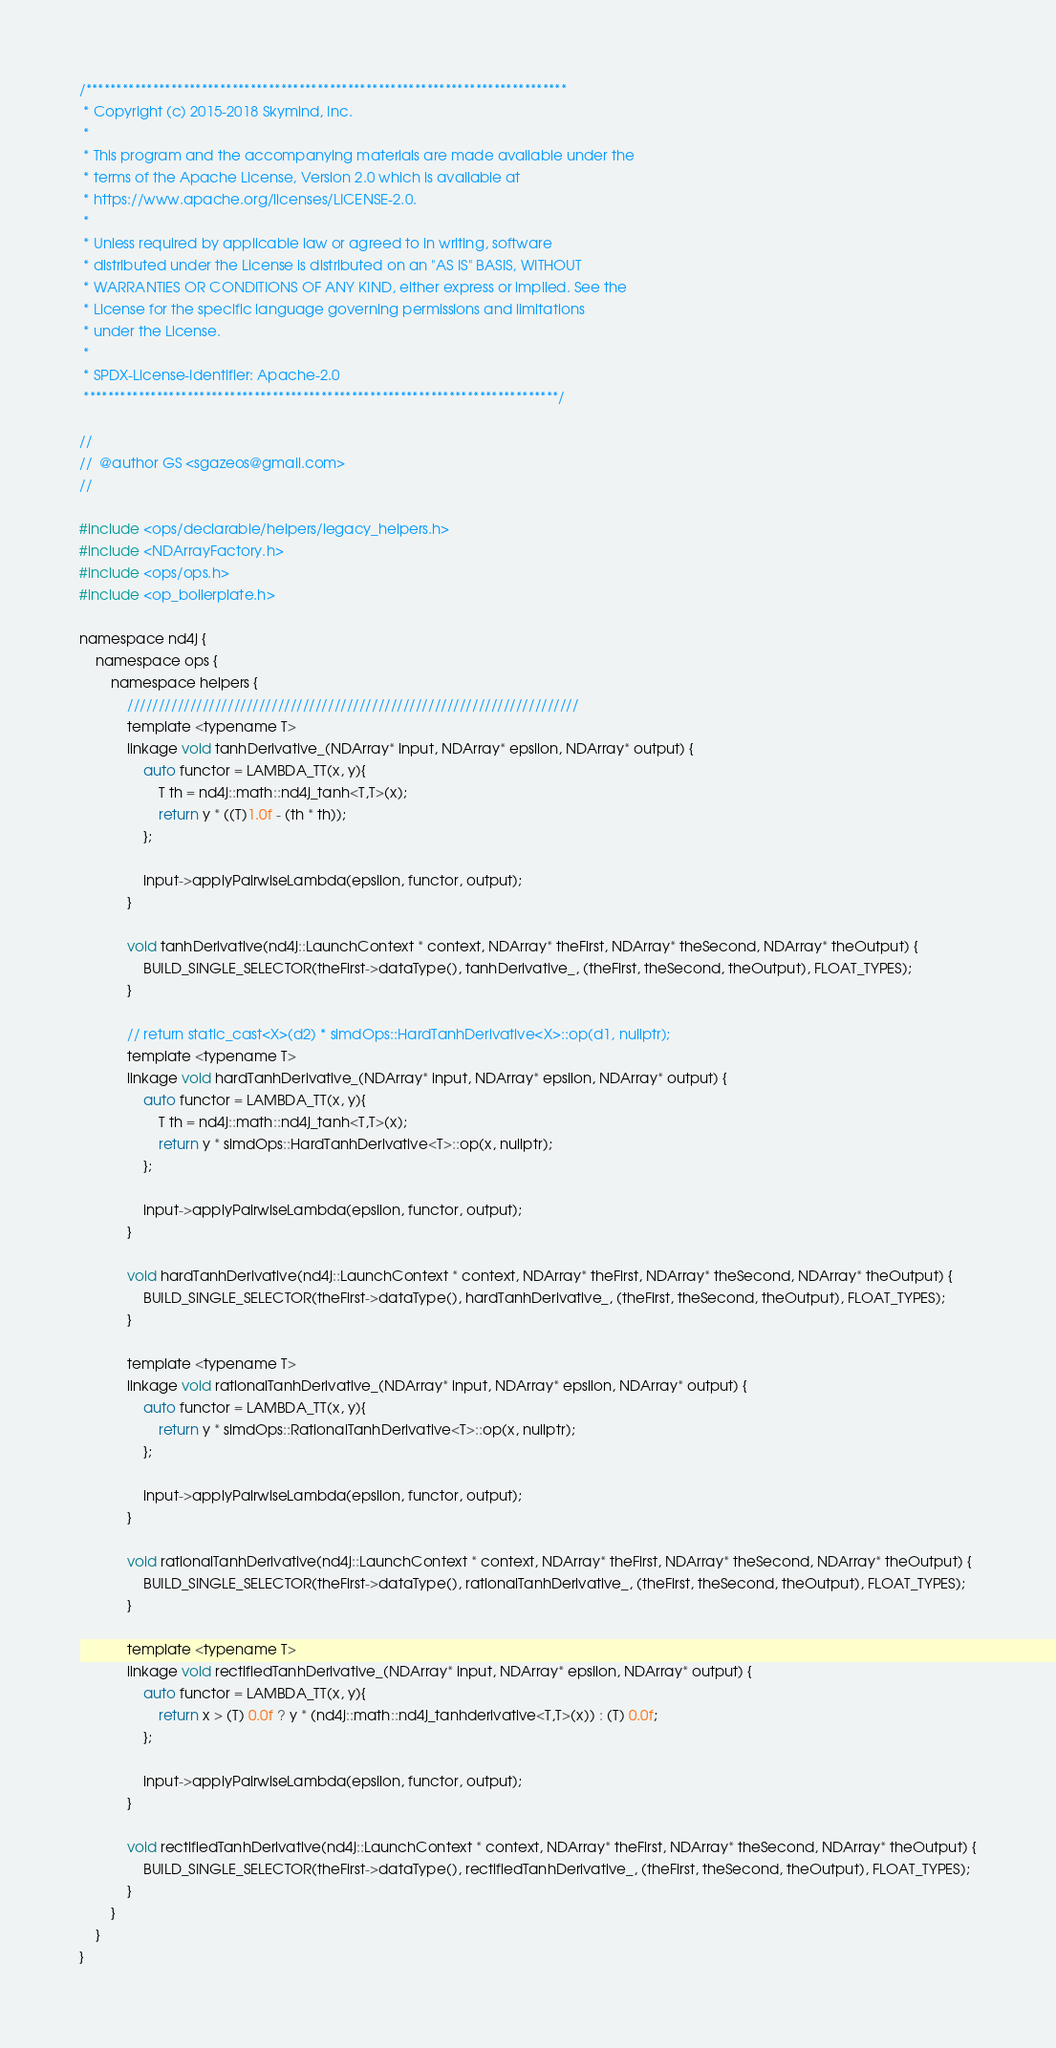Convert code to text. <code><loc_0><loc_0><loc_500><loc_500><_Cuda_>/*******************************************************************************
 * Copyright (c) 2015-2018 Skymind, Inc.
 *
 * This program and the accompanying materials are made available under the
 * terms of the Apache License, Version 2.0 which is available at
 * https://www.apache.org/licenses/LICENSE-2.0.
 *
 * Unless required by applicable law or agreed to in writing, software
 * distributed under the License is distributed on an "AS IS" BASIS, WITHOUT
 * WARRANTIES OR CONDITIONS OF ANY KIND, either express or implied. See the
 * License for the specific language governing permissions and limitations
 * under the License.
 *
 * SPDX-License-Identifier: Apache-2.0
 ******************************************************************************/

//
//  @author GS <sgazeos@gmail.com>
//

#include <ops/declarable/helpers/legacy_helpers.h>
#include <NDArrayFactory.h>
#include <ops/ops.h>
#include <op_boilerplate.h>

namespace nd4j {
    namespace ops {
        namespace helpers {
            ////////////////////////////////////////////////////////////////////////
            template <typename T>
            linkage void tanhDerivative_(NDArray* input, NDArray* epsilon, NDArray* output) {
                auto functor = LAMBDA_TT(x, y){
                    T th = nd4j::math::nd4j_tanh<T,T>(x);
                    return y * ((T)1.0f - (th * th));
                };

                input->applyPairwiseLambda(epsilon, functor, output);
            }

            void tanhDerivative(nd4j::LaunchContext * context, NDArray* theFirst, NDArray* theSecond, NDArray* theOutput) {
                BUILD_SINGLE_SELECTOR(theFirst->dataType(), tanhDerivative_, (theFirst, theSecond, theOutput), FLOAT_TYPES);
            }

            // return static_cast<X>(d2) * simdOps::HardTanhDerivative<X>::op(d1, nullptr);
            template <typename T>
            linkage void hardTanhDerivative_(NDArray* input, NDArray* epsilon, NDArray* output) {
                auto functor = LAMBDA_TT(x, y){
                    T th = nd4j::math::nd4j_tanh<T,T>(x);
                    return y * simdOps::HardTanhDerivative<T>::op(x, nullptr);
                };

                input->applyPairwiseLambda(epsilon, functor, output);
            }

            void hardTanhDerivative(nd4j::LaunchContext * context, NDArray* theFirst, NDArray* theSecond, NDArray* theOutput) {
                BUILD_SINGLE_SELECTOR(theFirst->dataType(), hardTanhDerivative_, (theFirst, theSecond, theOutput), FLOAT_TYPES);
            }

            template <typename T>
            linkage void rationalTanhDerivative_(NDArray* input, NDArray* epsilon, NDArray* output) {
                auto functor = LAMBDA_TT(x, y){
                    return y * simdOps::RationalTanhDerivative<T>::op(x, nullptr);
                };

                input->applyPairwiseLambda(epsilon, functor, output);
            }

            void rationalTanhDerivative(nd4j::LaunchContext * context, NDArray* theFirst, NDArray* theSecond, NDArray* theOutput) {
                BUILD_SINGLE_SELECTOR(theFirst->dataType(), rationalTanhDerivative_, (theFirst, theSecond, theOutput), FLOAT_TYPES);
            }

            template <typename T>
            linkage void rectifiedTanhDerivative_(NDArray* input, NDArray* epsilon, NDArray* output) {
                auto functor = LAMBDA_TT(x, y){
                    return x > (T) 0.0f ? y * (nd4j::math::nd4j_tanhderivative<T,T>(x)) : (T) 0.0f;
                };

                input->applyPairwiseLambda(epsilon, functor, output);
            }

            void rectifiedTanhDerivative(nd4j::LaunchContext * context, NDArray* theFirst, NDArray* theSecond, NDArray* theOutput) {
                BUILD_SINGLE_SELECTOR(theFirst->dataType(), rectifiedTanhDerivative_, (theFirst, theSecond, theOutput), FLOAT_TYPES);
            }
        }
    }
}</code> 